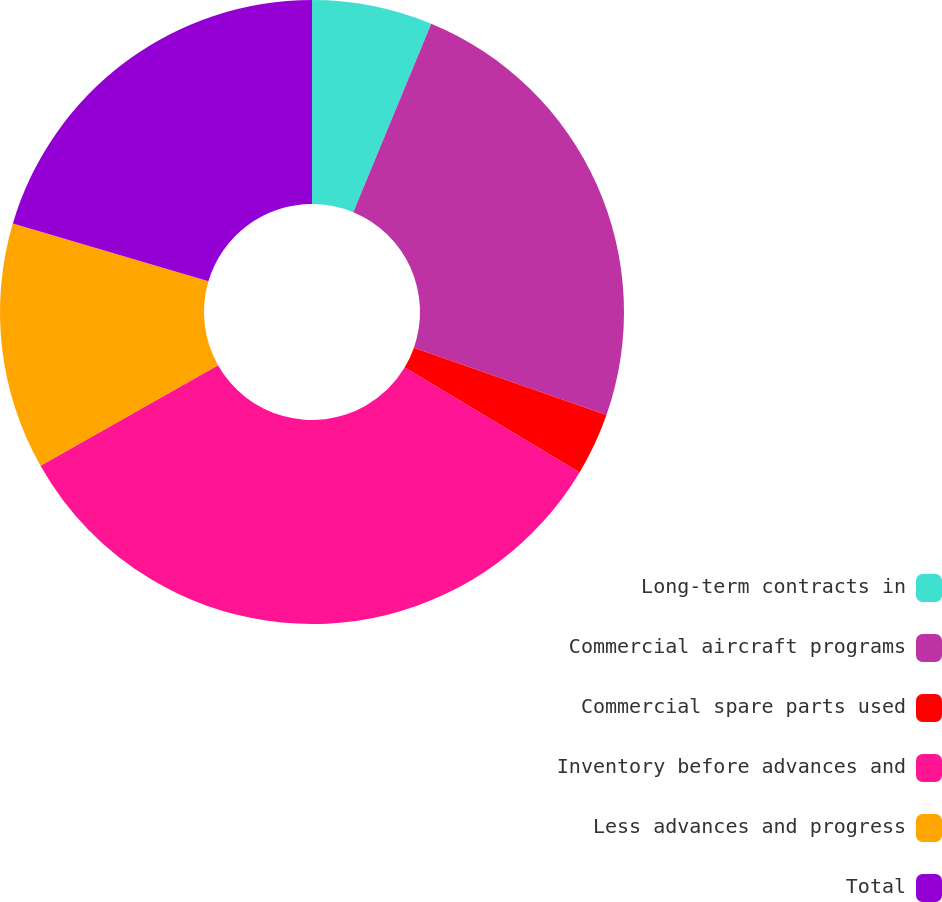Convert chart to OTSL. <chart><loc_0><loc_0><loc_500><loc_500><pie_chart><fcel>Long-term contracts in<fcel>Commercial aircraft programs<fcel>Commercial spare parts used<fcel>Inventory before advances and<fcel>Less advances and progress<fcel>Total<nl><fcel>6.24%<fcel>24.12%<fcel>3.24%<fcel>33.2%<fcel>12.78%<fcel>20.42%<nl></chart> 